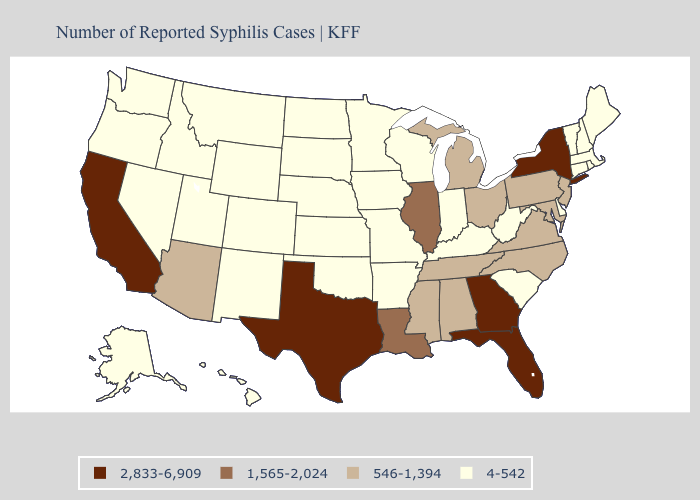Does Maryland have the lowest value in the USA?
Quick response, please. No. Which states hav the highest value in the Northeast?
Write a very short answer. New York. Name the states that have a value in the range 546-1,394?
Answer briefly. Alabama, Arizona, Maryland, Michigan, Mississippi, New Jersey, North Carolina, Ohio, Pennsylvania, Tennessee, Virginia. Does Pennsylvania have a lower value than New York?
Quick response, please. Yes. What is the value of Washington?
Answer briefly. 4-542. What is the lowest value in states that border South Dakota?
Concise answer only. 4-542. What is the value of Alabama?
Answer briefly. 546-1,394. Name the states that have a value in the range 2,833-6,909?
Concise answer only. California, Florida, Georgia, New York, Texas. What is the value of Michigan?
Write a very short answer. 546-1,394. What is the lowest value in the West?
Keep it brief. 4-542. What is the value of Montana?
Write a very short answer. 4-542. Among the states that border South Dakota , which have the highest value?
Keep it brief. Iowa, Minnesota, Montana, Nebraska, North Dakota, Wyoming. Is the legend a continuous bar?
Short answer required. No. What is the highest value in states that border Kentucky?
Short answer required. 1,565-2,024. Does Oklahoma have a higher value than South Carolina?
Be succinct. No. 